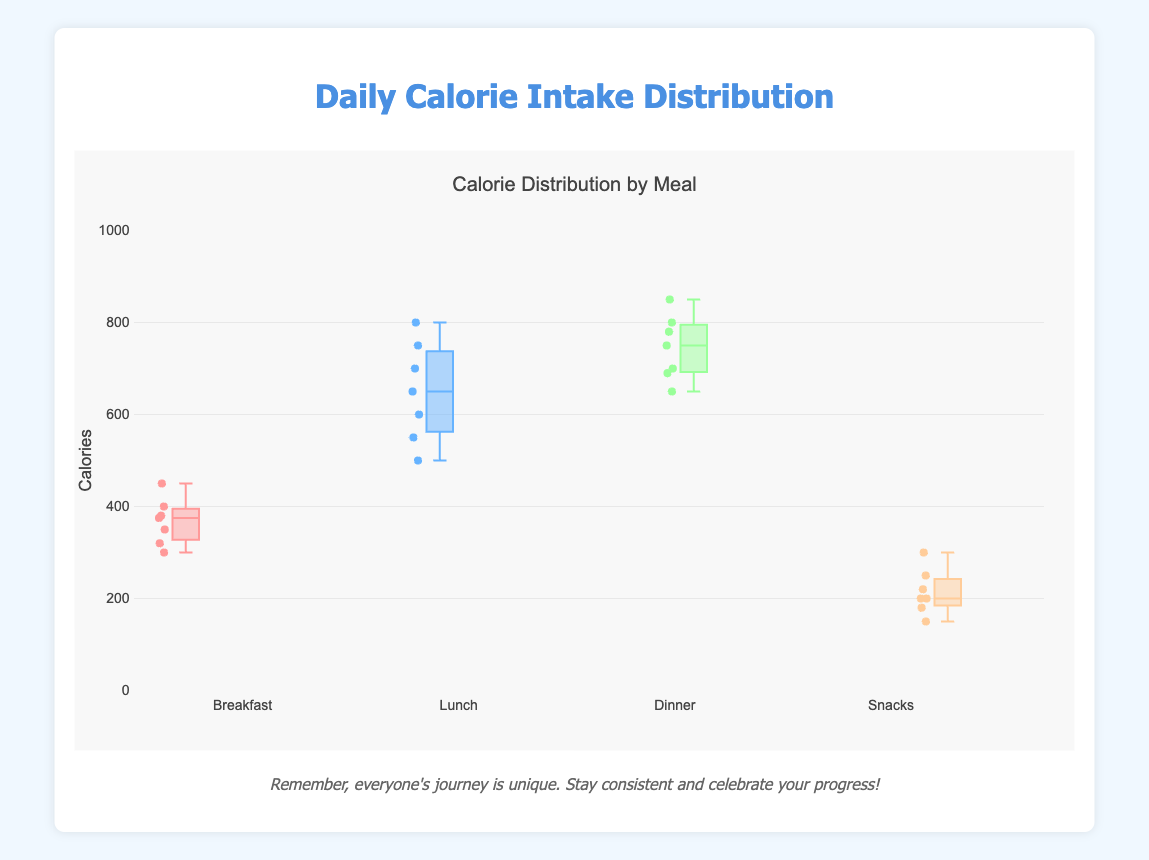What is the title of the figure? The title is found at the top of the figure, usually reflecting the general topic or focus of the plot. Here, it is displayed in the code as an attribute of the layout object.
Answer: Calorie Distribution by Meal Who has the highest calorie intake for dinner? To find this, look at the highest data point on the dinner box plot. The plot's points usually represent individuals, and the highest point there represents the individual with the highest calorie intake.
Answer: David Which meal has the widest range of calorie intake? The range is the difference between the maximum and minimum values in a distribution. The meal with the widest range will have the longest box plot. This is visible by comparing the length of the boxed sections for each meal.
Answer: Lunch What is the average calorie intake for breakfast? Sum the calorie values for breakfast and divide by the number of data points. The calorie intakes are: (350 + 400 + 300 + 450 + 375 + 380 + 320) / 7.
Answer: 368.57 How do the calorie intakes for snacks generally compare to dinner? Box plots show the distribution of data points. Compare the median line, the outer edges of the boxes (the interquartile range), and the whiskers (indicating the range). Snacks generally have lower calorie values compared to dinner.
Answer: Lower Which meal has the least variation in calorie intake? Variation in a box plot can be interpreted by the interquartile range (IQR). The meal with the smallest IQR (shortest box) shows the least variation.
Answer: Snacks What is the median calorie intake for lunch? The median is marked by the line in the center of the box in a box plot. Locate the line within the lunch box plot to find the median calorie intake.
Answer: 650 Is Alice's calorie intake at lunch above or below the median for lunch? Identify Alice's data point on the lunch box plot and compare it to the median line in the box plot. Alice's lunch intake is 600, and the median lunch intake is 650, so it is below.
Answer: Below Which meal's box plot has the highest upper whisker value? Identify the upper whisker for each meal’s box plot. The meal with the highest upper whisker indicates the maximum calorie intake recorded.
Answer: Dinner Are the calorie intakes for breakfast more or less variable compared to those for lunch? Compare the length of the boxes (which indicate the interquartile range, IQR) and the whiskers for both breakfast and lunch. Breakfast has a smaller IQR and shorter whiskers relative to lunch, indicating less variability.
Answer: Less 